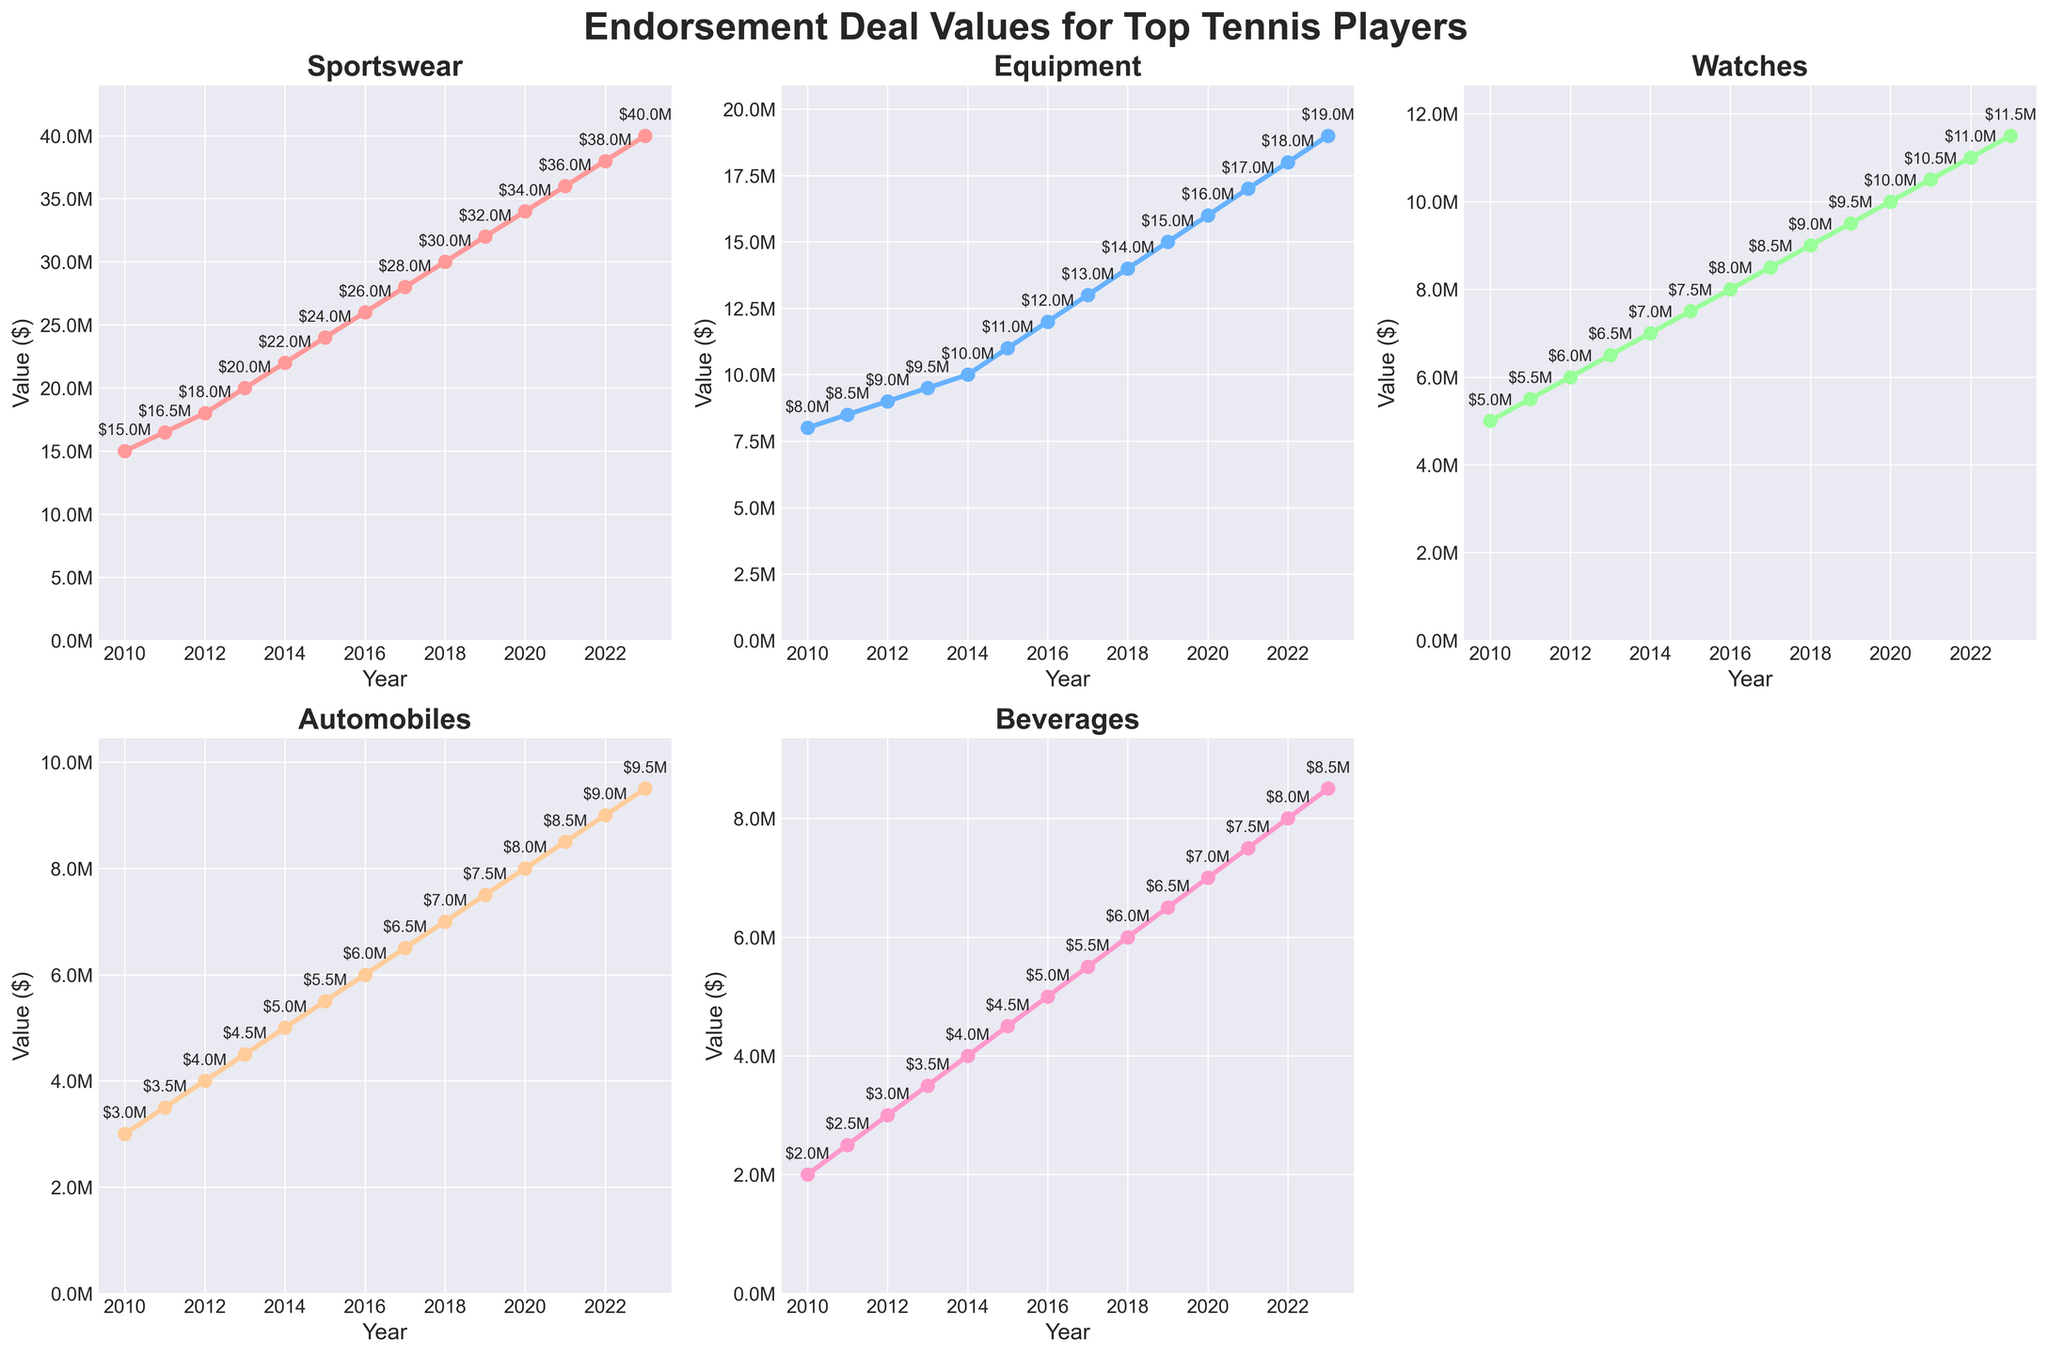What's the highest endorsement deal value shown in the figure? The highest endorsement values are in 2023 for all categories. By observing the plot, the peak value for 'Sportswear' reaches $40M which is the highest among all categories.
Answer: $40M Which category has shown the most steady growth over the years? By looking at the slope of the lines representing each category, the 'Sportswear' category has a consistent upward trajectory, indicating steady growth compared to others.
Answer: Sportswear In which year did the 'Equipment' endorsement value reach $15M? Observing the line plot for 'Equipment', the value hits $15M in the year 2019.
Answer: 2019 What is the total endorsement value of 'Watches' and 'Automobiles' in 2023? Refer to the 'Watches' and 'Automobiles' subplots for the year 2023. The 'Watches' value is $11.5M, and 'Automobiles' value is $9.5M. Adding these values: $11.5M + $9.5M = $21M.
Answer: $21M Which category experienced the fastest growth from 2010 to 2013? Calculate the increase from 2010 to 2013 for all categories. 'Sportswear' increased from $15M to $20M ($5M), 'Equipment' from $8M to $9.5M ($1.5M), 'Watches' from $5M to $6.5M ($1.5M), 'Automobiles' from $3M to $4.5M ($1.5M), 'Beverages' from $2M to $3.5M ($1.5M). 'Sportswear' grew by $5M, the highest increment.
Answer: Sportswear By how much did the 'Beverages' endorsement value increase between 2010 and 2020? The 'Beverages' subplot shows an increase from $2M in 2010 to $7M in 2020. The difference is $7M - $2M = $5M.
Answer: $5M Comparing 'Watches' and 'Beverages', which category had a higher endorsement value in 2015? Refer to the respective subplots for the year 2015. 'Watches' value is $7.5M, and 'Beverages' value is $4.5M. Thus, 'Watches' has a higher value.
Answer: Watches What is the average endorsement value for 'Sportswear' from 2010 to 2020? Sum the 'Sportswear' values for each year from 2010 to 2020 and divide by 11 (number of years). (15 + 16.5 + 18 + 20 + 22 + 24 + 26 + 28 + 30 + 32 + 34)/11 = 27.3.
Answer: $27.3M Which category saw its endorsement value double within the shortest time span? 'Automobiles' increased from $3M in 2010 to $6M in 2016, doubling in 6 years. Other categories took longer to double, making 'Automobiles' the fastest to double.
Answer: Automobiles 